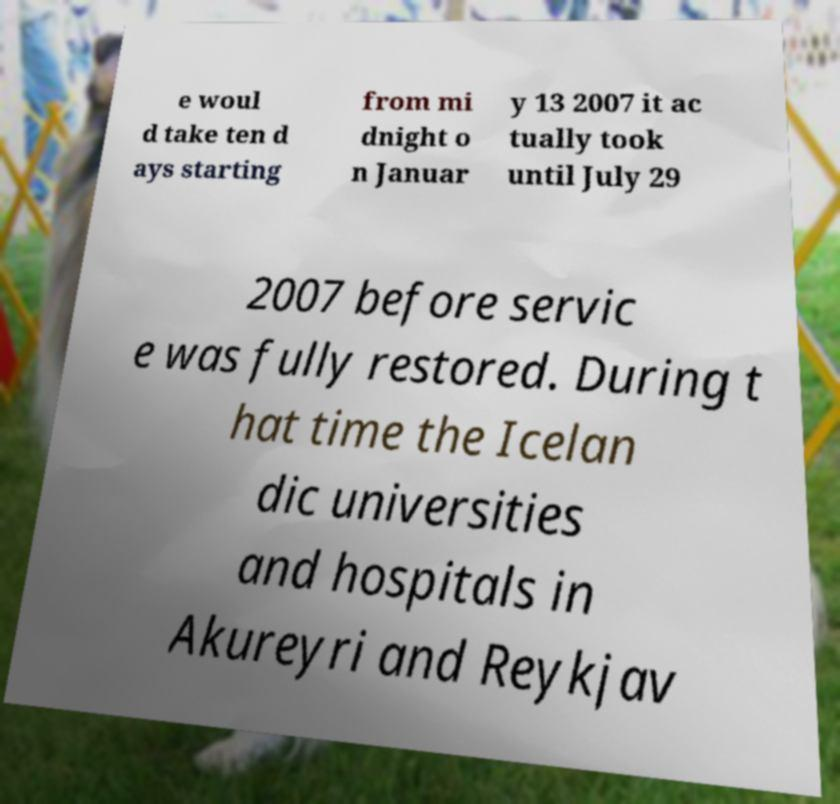Can you accurately transcribe the text from the provided image for me? e woul d take ten d ays starting from mi dnight o n Januar y 13 2007 it ac tually took until July 29 2007 before servic e was fully restored. During t hat time the Icelan dic universities and hospitals in Akureyri and Reykjav 